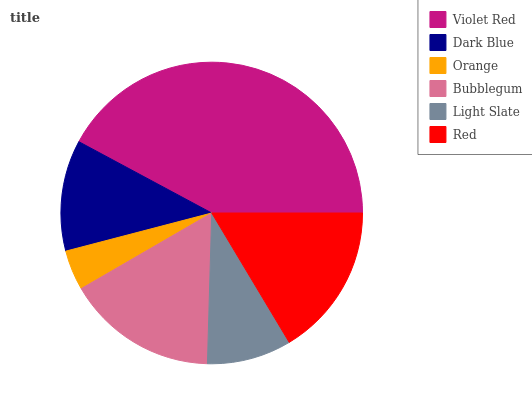Is Orange the minimum?
Answer yes or no. Yes. Is Violet Red the maximum?
Answer yes or no. Yes. Is Dark Blue the minimum?
Answer yes or no. No. Is Dark Blue the maximum?
Answer yes or no. No. Is Violet Red greater than Dark Blue?
Answer yes or no. Yes. Is Dark Blue less than Violet Red?
Answer yes or no. Yes. Is Dark Blue greater than Violet Red?
Answer yes or no. No. Is Violet Red less than Dark Blue?
Answer yes or no. No. Is Bubblegum the high median?
Answer yes or no. Yes. Is Dark Blue the low median?
Answer yes or no. Yes. Is Light Slate the high median?
Answer yes or no. No. Is Orange the low median?
Answer yes or no. No. 